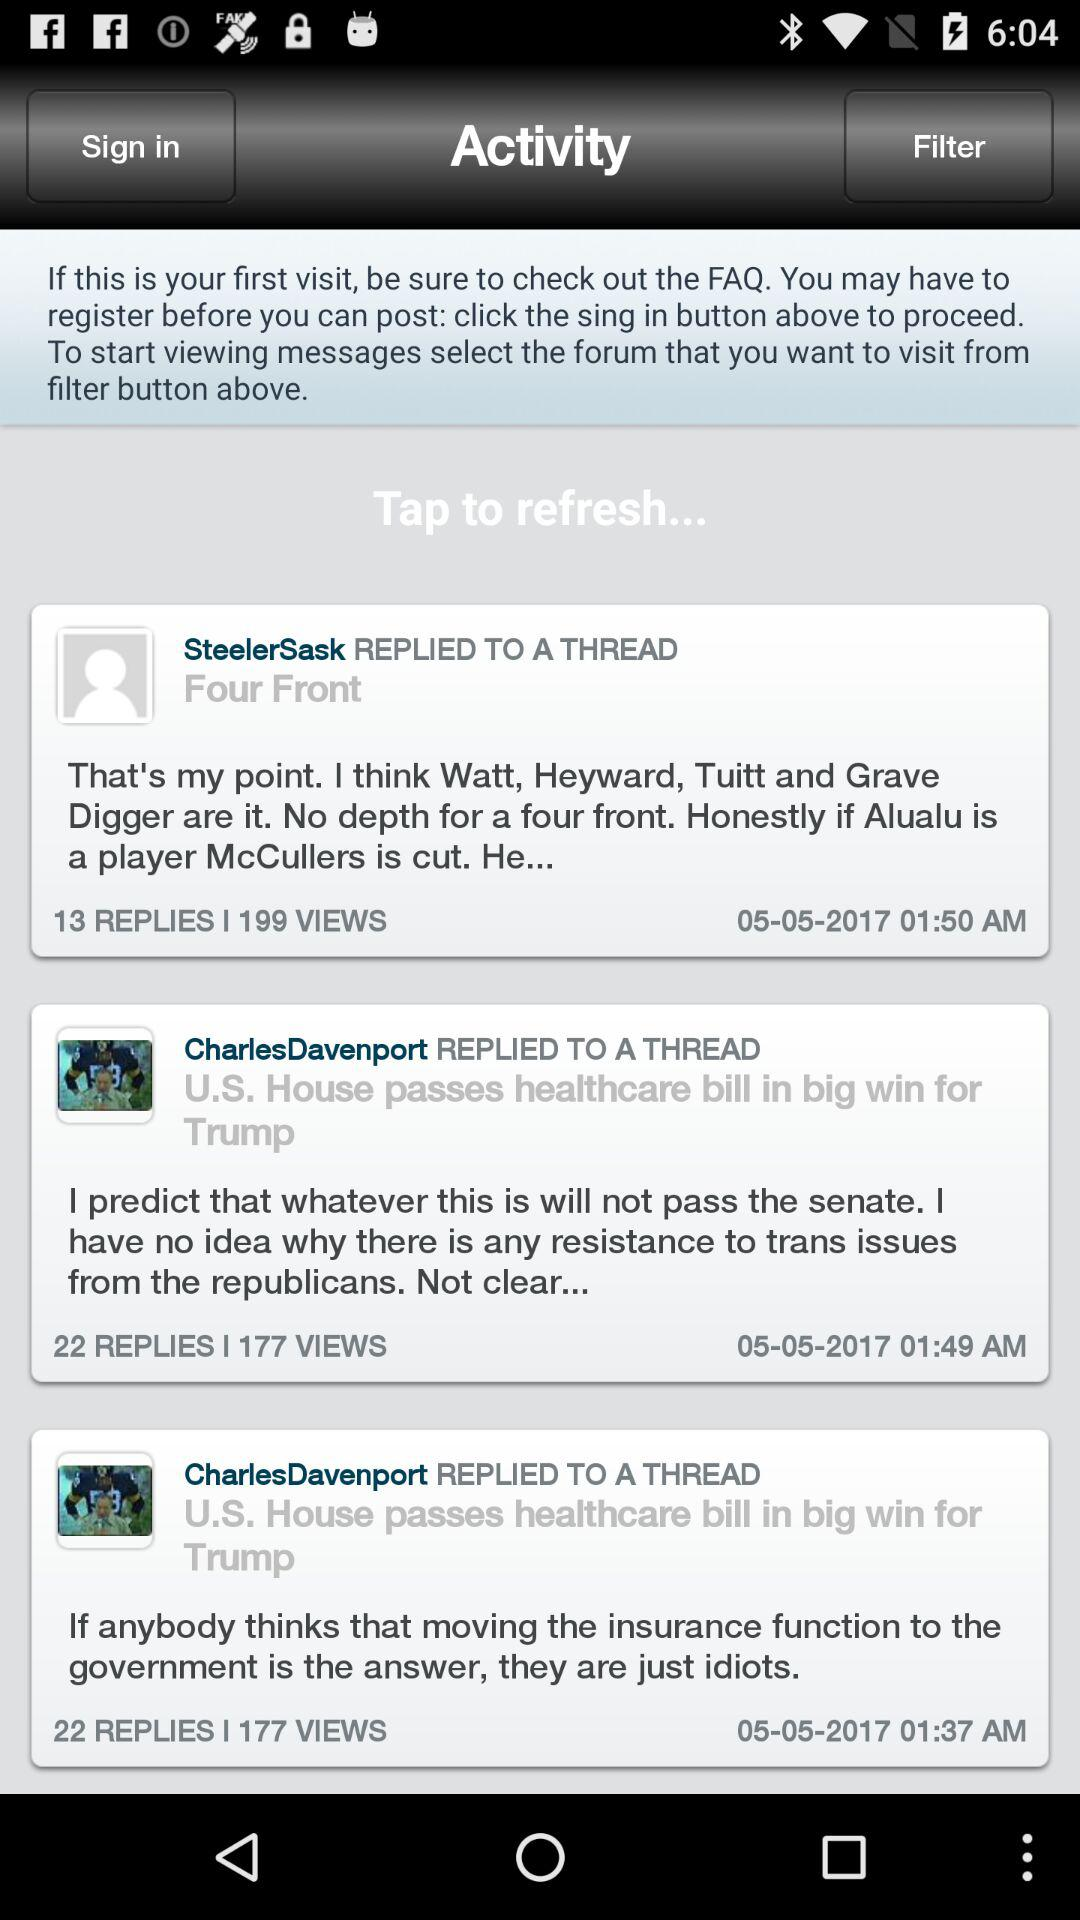What are the available filters?
When the provided information is insufficient, respond with <no answer>. <no answer> 